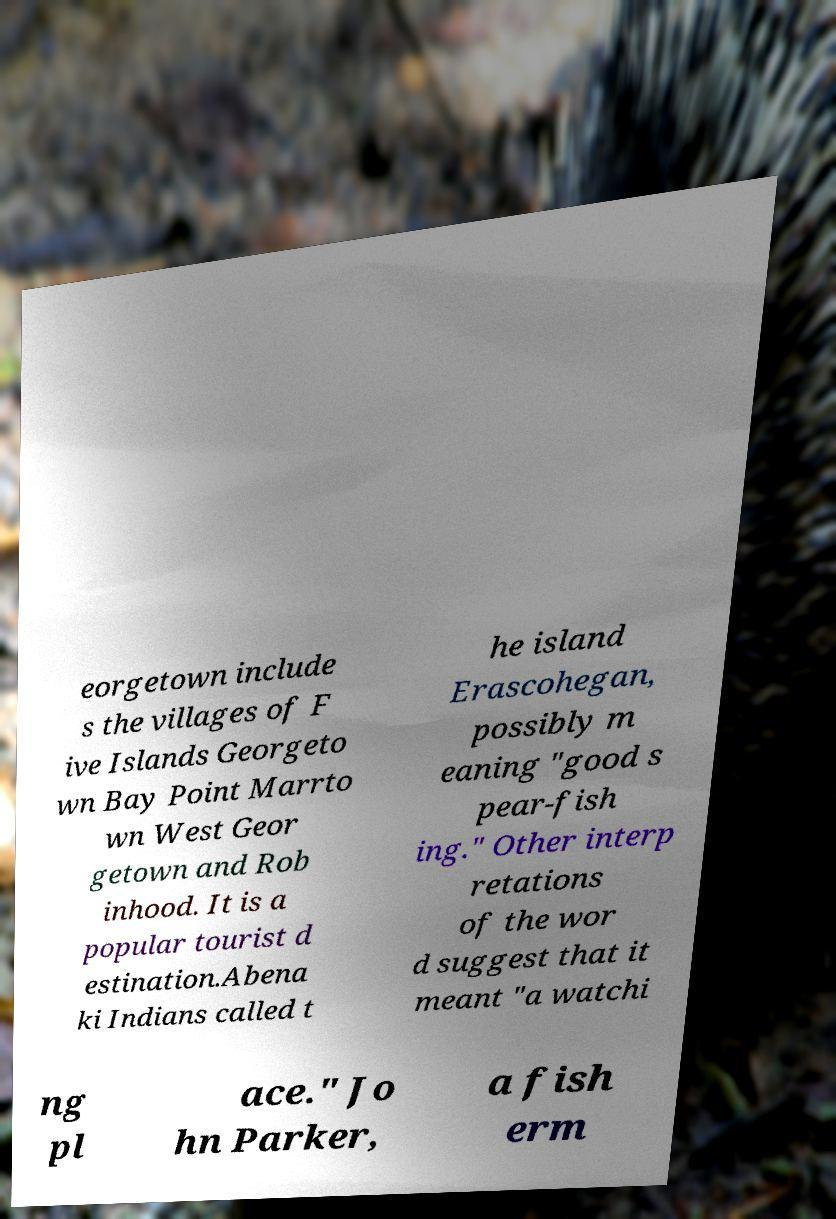What messages or text are displayed in this image? I need them in a readable, typed format. eorgetown include s the villages of F ive Islands Georgeto wn Bay Point Marrto wn West Geor getown and Rob inhood. It is a popular tourist d estination.Abena ki Indians called t he island Erascohegan, possibly m eaning "good s pear-fish ing." Other interp retations of the wor d suggest that it meant "a watchi ng pl ace." Jo hn Parker, a fish erm 